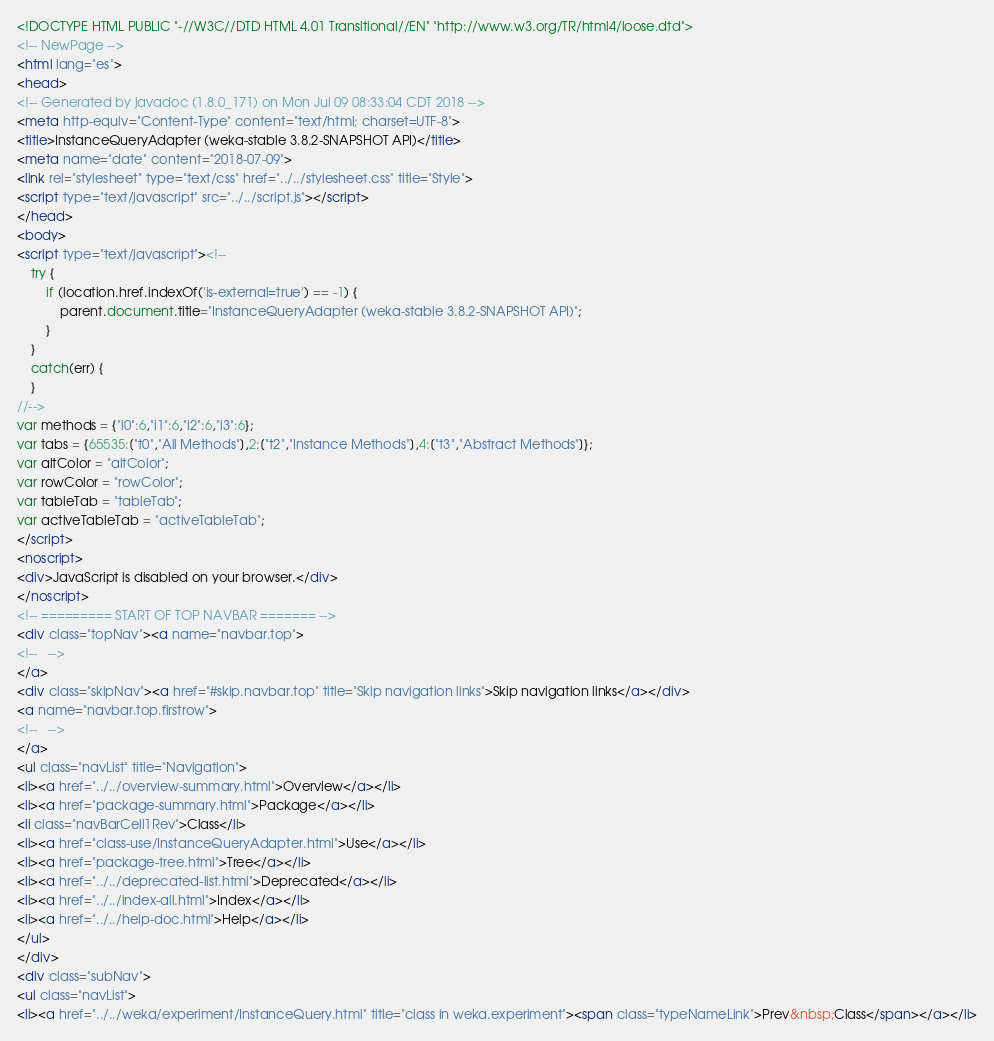Convert code to text. <code><loc_0><loc_0><loc_500><loc_500><_HTML_><!DOCTYPE HTML PUBLIC "-//W3C//DTD HTML 4.01 Transitional//EN" "http://www.w3.org/TR/html4/loose.dtd">
<!-- NewPage -->
<html lang="es">
<head>
<!-- Generated by javadoc (1.8.0_171) on Mon Jul 09 08:33:04 CDT 2018 -->
<meta http-equiv="Content-Type" content="text/html; charset=UTF-8">
<title>InstanceQueryAdapter (weka-stable 3.8.2-SNAPSHOT API)</title>
<meta name="date" content="2018-07-09">
<link rel="stylesheet" type="text/css" href="../../stylesheet.css" title="Style">
<script type="text/javascript" src="../../script.js"></script>
</head>
<body>
<script type="text/javascript"><!--
    try {
        if (location.href.indexOf('is-external=true') == -1) {
            parent.document.title="InstanceQueryAdapter (weka-stable 3.8.2-SNAPSHOT API)";
        }
    }
    catch(err) {
    }
//-->
var methods = {"i0":6,"i1":6,"i2":6,"i3":6};
var tabs = {65535:["t0","All Methods"],2:["t2","Instance Methods"],4:["t3","Abstract Methods"]};
var altColor = "altColor";
var rowColor = "rowColor";
var tableTab = "tableTab";
var activeTableTab = "activeTableTab";
</script>
<noscript>
<div>JavaScript is disabled on your browser.</div>
</noscript>
<!-- ========= START OF TOP NAVBAR ======= -->
<div class="topNav"><a name="navbar.top">
<!--   -->
</a>
<div class="skipNav"><a href="#skip.navbar.top" title="Skip navigation links">Skip navigation links</a></div>
<a name="navbar.top.firstrow">
<!--   -->
</a>
<ul class="navList" title="Navigation">
<li><a href="../../overview-summary.html">Overview</a></li>
<li><a href="package-summary.html">Package</a></li>
<li class="navBarCell1Rev">Class</li>
<li><a href="class-use/InstanceQueryAdapter.html">Use</a></li>
<li><a href="package-tree.html">Tree</a></li>
<li><a href="../../deprecated-list.html">Deprecated</a></li>
<li><a href="../../index-all.html">Index</a></li>
<li><a href="../../help-doc.html">Help</a></li>
</ul>
</div>
<div class="subNav">
<ul class="navList">
<li><a href="../../weka/experiment/InstanceQuery.html" title="class in weka.experiment"><span class="typeNameLink">Prev&nbsp;Class</span></a></li></code> 